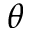Convert formula to latex. <formula><loc_0><loc_0><loc_500><loc_500>\theta</formula> 